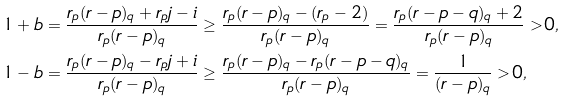<formula> <loc_0><loc_0><loc_500><loc_500>1 + b & = \frac { r _ { p } ( r - p ) _ { q } + r _ { p } j - i } { r _ { p } ( r - p ) _ { q } } \geq \frac { r _ { p } ( r - p ) _ { q } - ( r _ { p } - 2 ) } { r _ { p } ( r - p ) _ { q } } = \frac { r _ { p } ( r - p - q ) _ { q } + 2 } { r _ { p } ( r - p ) _ { q } } > 0 , \\ 1 - b & = \frac { r _ { p } ( r - p ) _ { q } - r _ { p } j + i } { r _ { p } ( r - p ) _ { q } } \geq \frac { r _ { p } ( r - p ) _ { q } - r _ { p } ( r - p - q ) _ { q } } { r _ { p } ( r - p ) _ { q } } = \frac { 1 } { ( r - p ) _ { q } } > 0 ,</formula> 